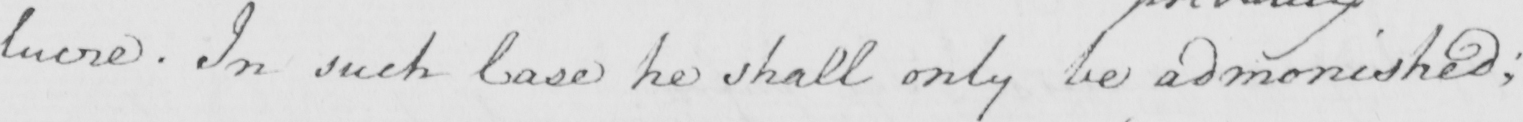Please provide the text content of this handwritten line. lucre . In such Case he shall only be admonished ; 